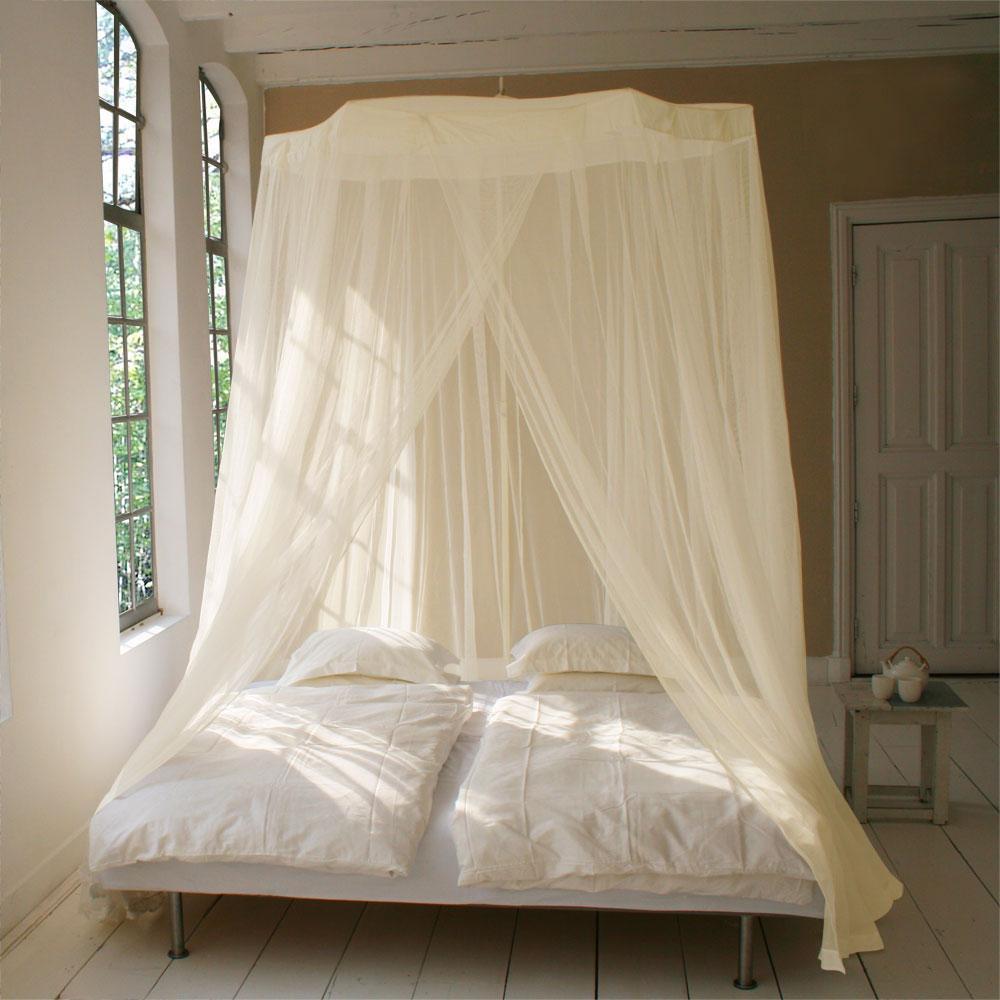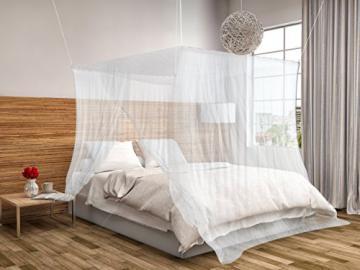The first image is the image on the left, the second image is the image on the right. Given the left and right images, does the statement "There is a baby visible in one image." hold true? Answer yes or no. No. The first image is the image on the left, the second image is the image on the right. Evaluate the accuracy of this statement regarding the images: "The left and right image contains a total of two open canopies.". Is it true? Answer yes or no. Yes. 